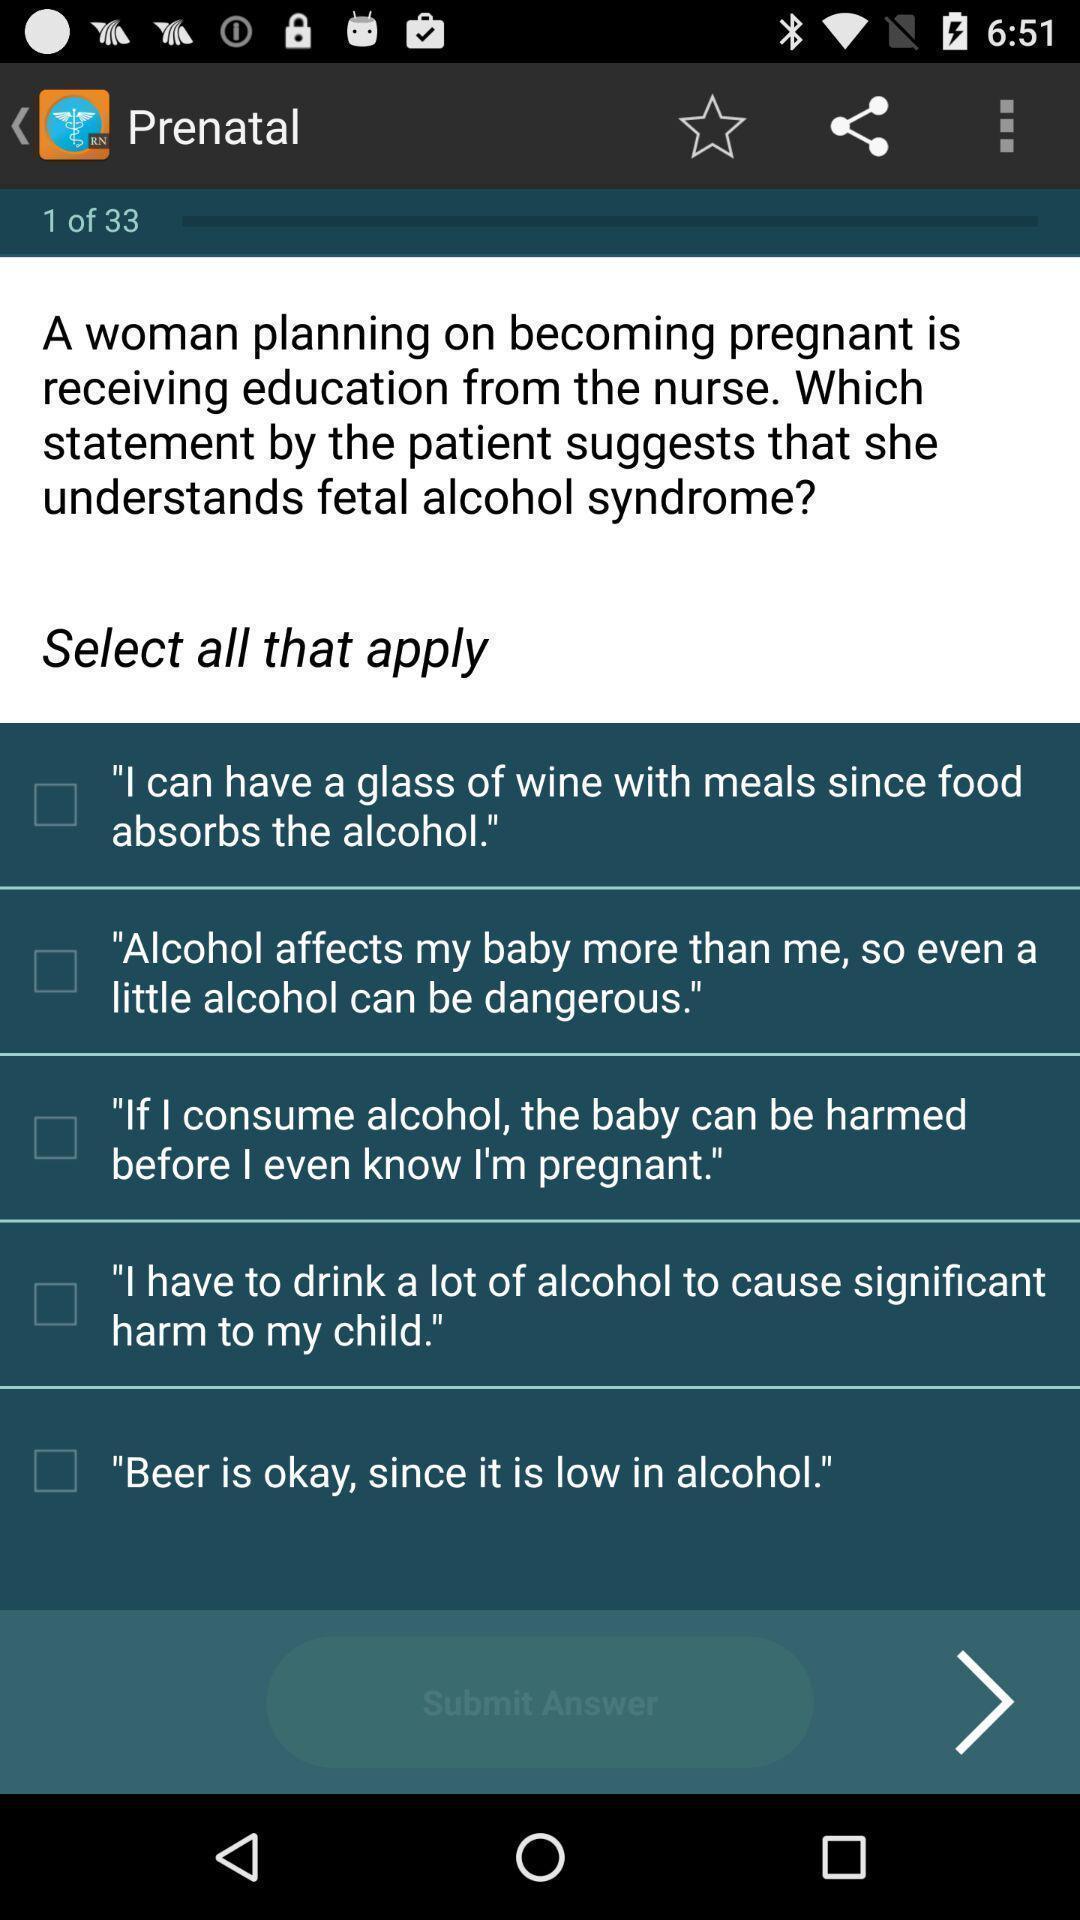Provide a detailed account of this screenshot. Screen displaying questionnaire page of a parenting app. 